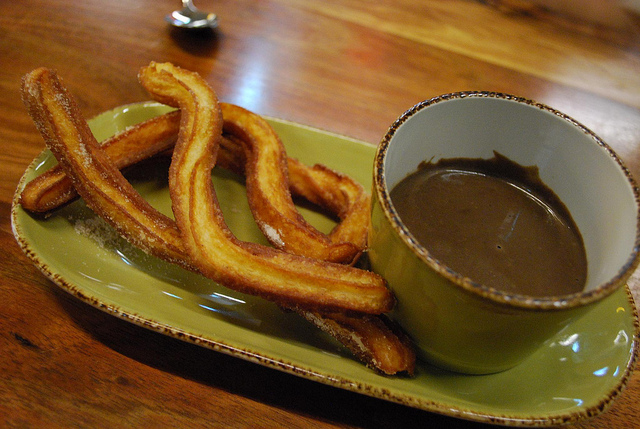What kind of dish are the cups sitting on? The cups are sitting on a green saucer that complements the overall color scheme. 